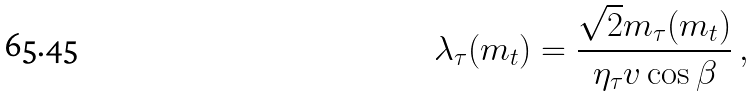Convert formula to latex. <formula><loc_0><loc_0><loc_500><loc_500>\lambda _ { \tau } ( m _ { t } ) = { \frac { \sqrt { 2 } m _ { \tau } ( m _ { t } ) } { \eta _ { \tau } v \cos \beta } } \, ,</formula> 